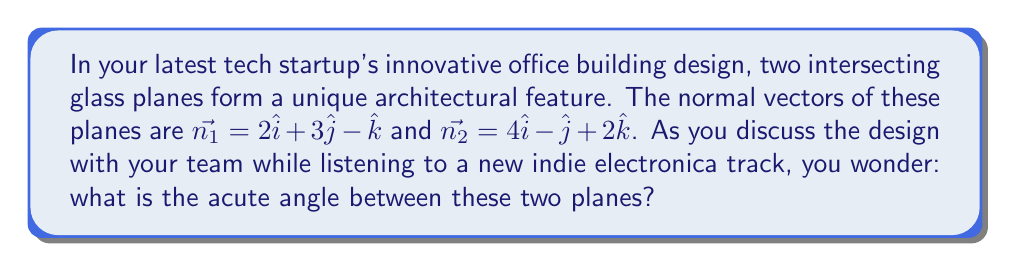Can you answer this question? To find the angle between two intersecting planes, we can use the dot product of their normal vectors. The formula for the angle $\theta$ between two planes with normal vectors $\vec{n_1}$ and $\vec{n_2}$ is:

$$\cos \theta = \frac{|\vec{n_1} \cdot \vec{n_2}|}{|\vec{n_1}| |\vec{n_2}|}$$

Let's solve this step-by-step:

1) First, calculate the dot product $\vec{n_1} \cdot \vec{n_2}$:
   $$\vec{n_1} \cdot \vec{n_2} = (2)(4) + (3)(-1) + (-1)(2) = 8 - 3 - 2 = 3$$

2) Calculate the magnitudes of $\vec{n_1}$ and $\vec{n_2}$:
   $$|\vec{n_1}| = \sqrt{2^2 + 3^2 + (-1)^2} = \sqrt{4 + 9 + 1} = \sqrt{14}$$
   $$|\vec{n_2}| = \sqrt{4^2 + (-1)^2 + 2^2} = \sqrt{16 + 1 + 4} = \sqrt{21}$$

3) Now, substitute these values into the formula:
   $$\cos \theta = \frac{|3|}{\sqrt{14} \sqrt{21}} = \frac{3}{\sqrt{294}}$$

4) To find $\theta$, take the inverse cosine (arccos) of both sides:
   $$\theta = \arccos(\frac{3}{\sqrt{294}})$$

5) Calculate this value:
   $$\theta \approx 1.3729 \text{ radians}$$

6) Convert to degrees:
   $$\theta \approx 78.63°$$

This is the acute angle between the planes. The obtuse angle would be $180° - 78.63° = 101.37°$.
Answer: The acute angle between the two intersecting planes is approximately 78.63°. 